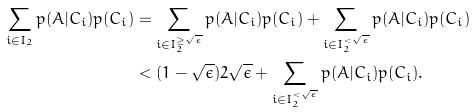Convert formula to latex. <formula><loc_0><loc_0><loc_500><loc_500>\sum _ { i \in I _ { 2 } } p ( A | C _ { i } ) p ( C _ { i } ) & = \sum _ { i \in I _ { 2 } ^ { \geq \sqrt { \epsilon } } } p ( A | C _ { i } ) p ( C _ { i } ) + \sum _ { i \in I _ { 2 } ^ { < \sqrt { \epsilon } } } p ( A | C _ { i } ) p ( C _ { i } ) \\ & < ( 1 - \sqrt { \epsilon } ) 2 \sqrt { \epsilon } + \sum _ { i \in I _ { 2 } ^ { < \sqrt { \epsilon } } } p ( A | C _ { i } ) p ( C _ { i } ) .</formula> 